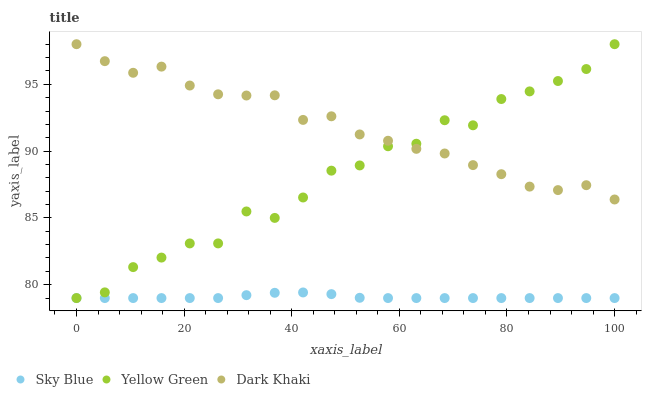Does Sky Blue have the minimum area under the curve?
Answer yes or no. Yes. Does Dark Khaki have the maximum area under the curve?
Answer yes or no. Yes. Does Yellow Green have the minimum area under the curve?
Answer yes or no. No. Does Yellow Green have the maximum area under the curve?
Answer yes or no. No. Is Sky Blue the smoothest?
Answer yes or no. Yes. Is Yellow Green the roughest?
Answer yes or no. Yes. Is Yellow Green the smoothest?
Answer yes or no. No. Is Sky Blue the roughest?
Answer yes or no. No. Does Sky Blue have the lowest value?
Answer yes or no. Yes. Does Yellow Green have the highest value?
Answer yes or no. Yes. Does Sky Blue have the highest value?
Answer yes or no. No. Is Sky Blue less than Dark Khaki?
Answer yes or no. Yes. Is Dark Khaki greater than Sky Blue?
Answer yes or no. Yes. Does Yellow Green intersect Sky Blue?
Answer yes or no. Yes. Is Yellow Green less than Sky Blue?
Answer yes or no. No. Is Yellow Green greater than Sky Blue?
Answer yes or no. No. Does Sky Blue intersect Dark Khaki?
Answer yes or no. No. 